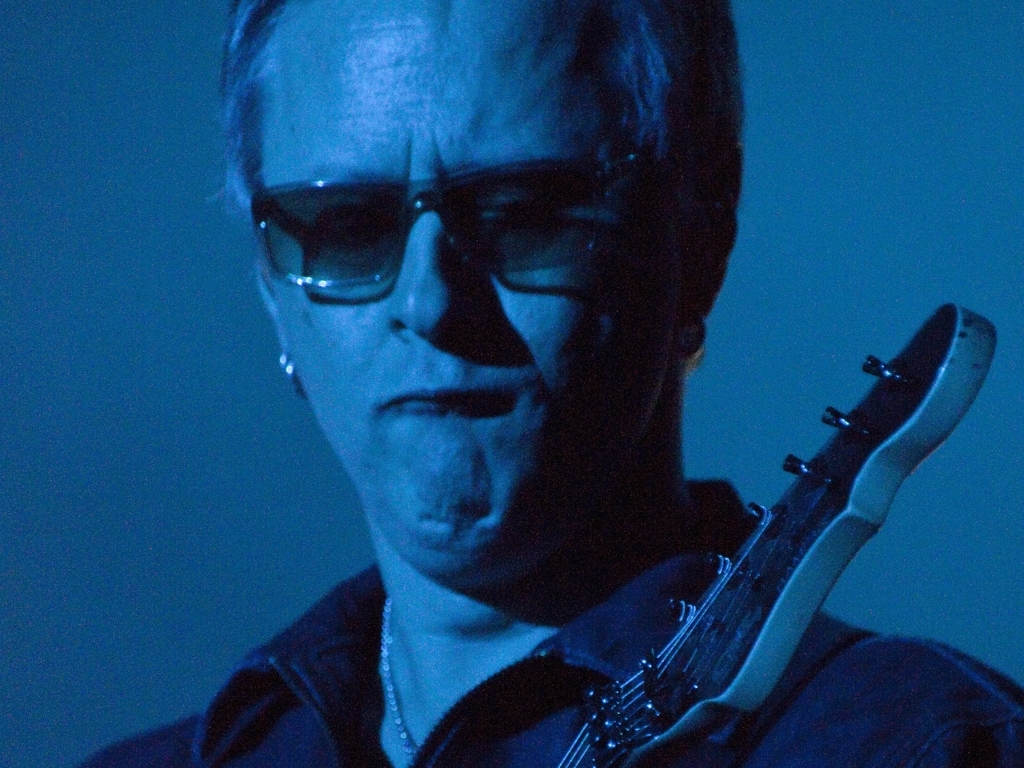Considering the subject is playing a guitar, what might be the setting or event where this photograph was taken? Judging from the subject's focus and the artistic way the photo is taken, it's likely that this image was captured during a live music performance, possibly at a concert or an intimate gig. The close-up perspective and the dramatic lighting suggest that the photograph is aiming to capture the intensity and passion of the performer, which are often highlighted in live musical settings. 